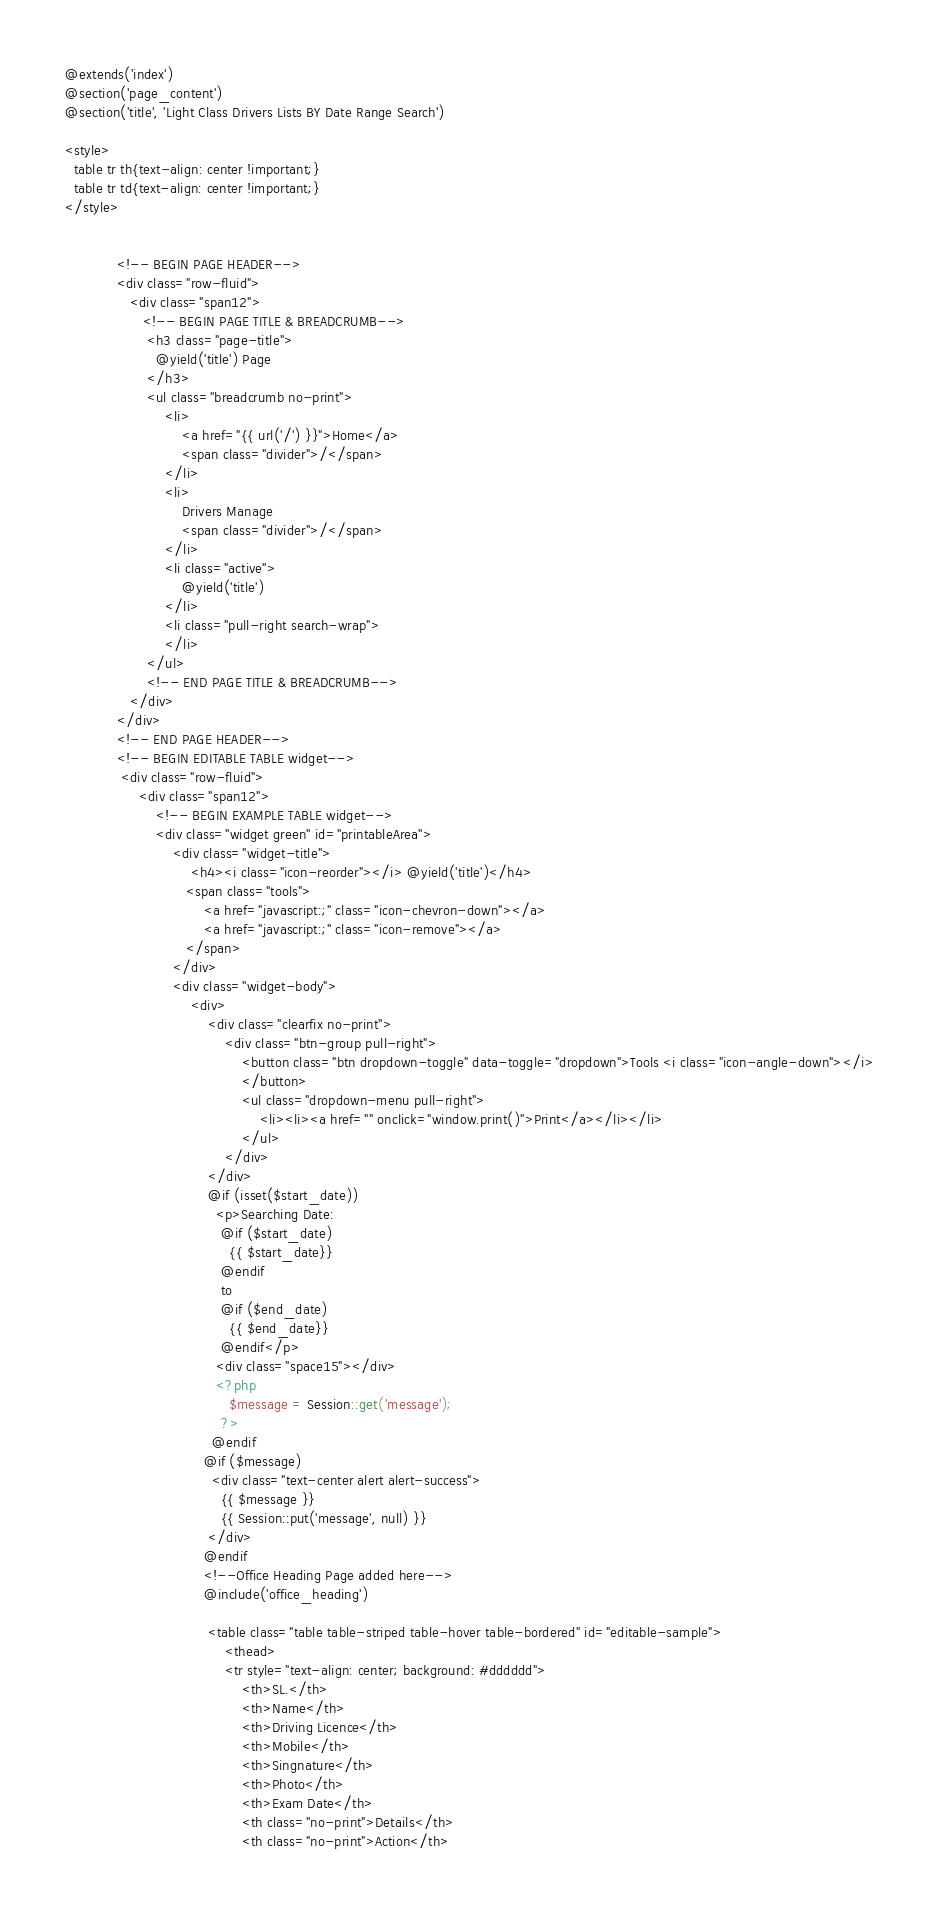Convert code to text. <code><loc_0><loc_0><loc_500><loc_500><_PHP_>@extends('index')
@section('page_content')
@section('title', 'Light Class Drivers Lists BY Date Range Search')

<style>
  table tr th{text-align: center !important;}
  table tr td{text-align: center !important;}
</style>


            <!-- BEGIN PAGE HEADER-->   
            <div class="row-fluid">
               <div class="span12">
                  <!-- BEGIN PAGE TITLE & BREADCRUMB-->
                   <h3 class="page-title">
                     @yield('title') Page
                   </h3>
                   <ul class="breadcrumb no-print">
                       <li>
                           <a href="{{ url('/') }}">Home</a>
                           <span class="divider">/</span>
                       </li>
                       <li>
                           Drivers Manage
                           <span class="divider">/</span>
                       </li>
                       <li class="active">
                           @yield('title')
                       </li>
                       <li class="pull-right search-wrap">
                       </li>
                   </ul>
                   <!-- END PAGE TITLE & BREADCRUMB-->
               </div>
            </div>
            <!-- END PAGE HEADER-->
            <!-- BEGIN EDITABLE TABLE widget-->
             <div class="row-fluid">
                 <div class="span12">
                     <!-- BEGIN EXAMPLE TABLE widget-->
                     <div class="widget green" id="printableArea">
                         <div class="widget-title">
                             <h4><i class="icon-reorder"></i> @yield('title')</h4>
                            <span class="tools">
                                <a href="javascript:;" class="icon-chevron-down"></a>
                                <a href="javascript:;" class="icon-remove"></a>
                            </span>
                         </div>
                         <div class="widget-body">
                             <div>
                                 <div class="clearfix no-print">
                                     <div class="btn-group pull-right">
                                         <button class="btn dropdown-toggle" data-toggle="dropdown">Tools <i class="icon-angle-down"></i>
                                         </button>
                                         <ul class="dropdown-menu pull-right">
                                             <li><li><a href="" onclick="window.print()">Print</a></li></li>
                                         </ul>
                                     </div>
                                 </div>
                                 @if (isset($start_date))
                                   <p>Searching Date: 
                                    @if ($start_date)
                                      {{ $start_date}}
                                    @endif
                                    to 
                                    @if ($end_date)
                                      {{ $end_date}}
                                    @endif</p>
                                   <div class="space15"></div>
                                   <?php
                                      $message = Session::get('message');
                                    ?>
                                  @endif
                                @if ($message)
                                  <div class="text-center alert alert-success">
                                    {{ $message }}
                                    {{ Session::put('message', null) }}
                                 </div>
                                @endif
                                <!--Office Heading Page added here-->
                                @include('office_heading')

                                 <table class="table table-striped table-hover table-bordered" id="editable-sample">
                                     <thead>
                                     <tr style="text-align: center; background: #dddddd">
                                         <th>SL.</th>
                                         <th>Name</th>
                                         <th>Driving Licence</th>
                                         <th>Mobile</th>
                                         <th>Singnature</th>
                                         <th>Photo</th>
                                         <th>Exam Date</th>
                                         <th class="no-print">Details</th>
                                         <th class="no-print">Action</th></code> 